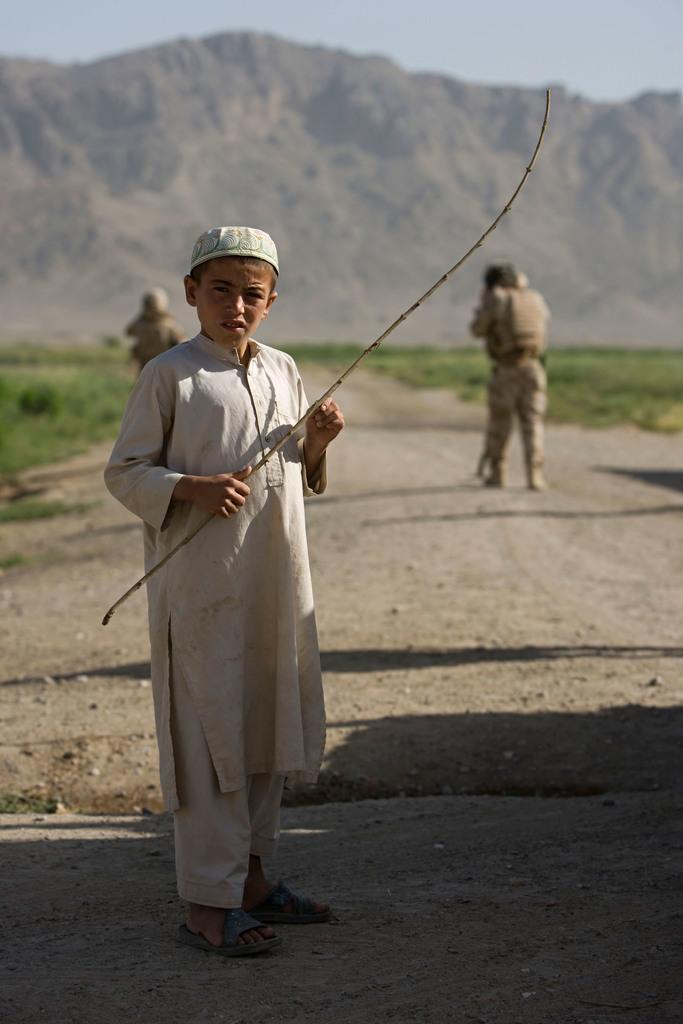Could you give a brief overview of what you see in this image? In this image there is a boy standing on a path holding a stick in his hand, in the background there are two people walking and there is grassland, mountain and the sky. 